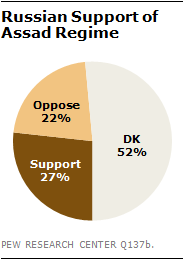List a handful of essential elements in this visual. The color of support is represented as dark brown. 